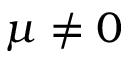Convert formula to latex. <formula><loc_0><loc_0><loc_500><loc_500>\mu \neq 0</formula> 